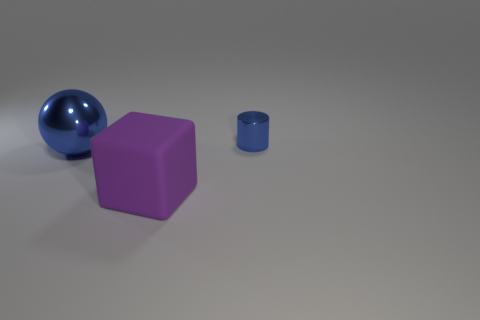Add 3 big blocks. How many objects exist? 6 Subtract all cylinders. How many objects are left? 2 Add 2 blocks. How many blocks exist? 3 Subtract 0 green cylinders. How many objects are left? 3 Subtract all big yellow cylinders. Subtract all tiny metal things. How many objects are left? 2 Add 2 purple rubber things. How many purple rubber things are left? 3 